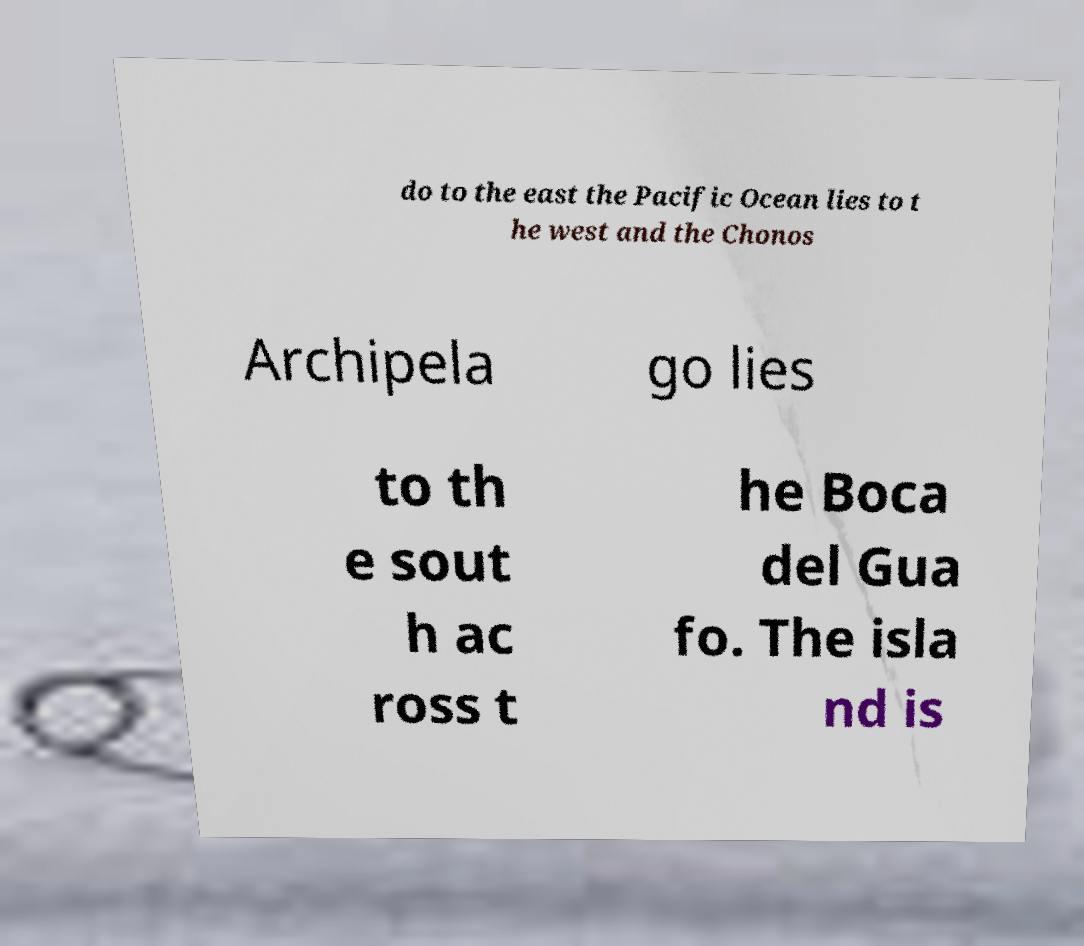For documentation purposes, I need the text within this image transcribed. Could you provide that? do to the east the Pacific Ocean lies to t he west and the Chonos Archipela go lies to th e sout h ac ross t he Boca del Gua fo. The isla nd is 